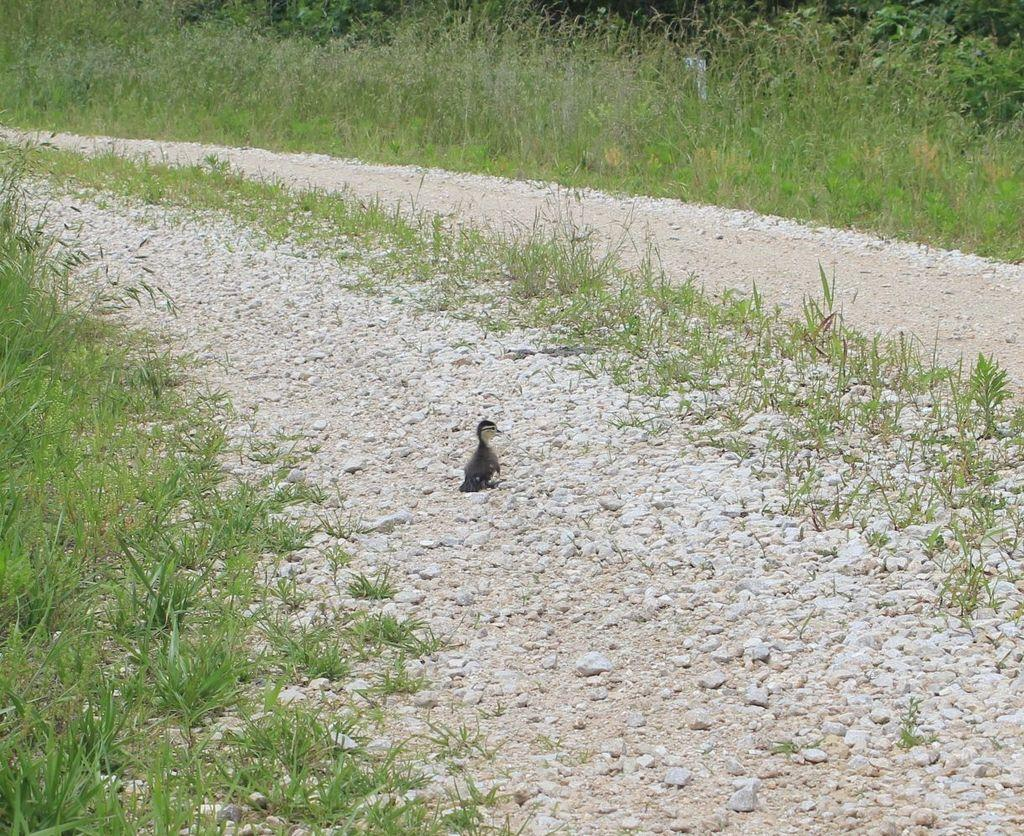What is the main subject in the center of the image? There is a bird in the center of the image. What can be seen at the bottom of the image? There are stones and grass at the bottom of the image. What is the father's wealth in the image? There is no reference to a father or wealth in the image, so it cannot be determined. 